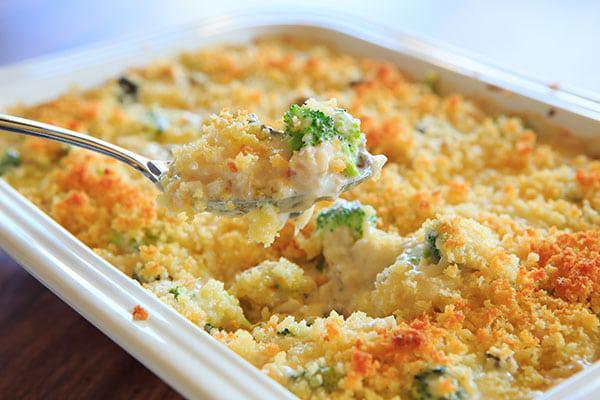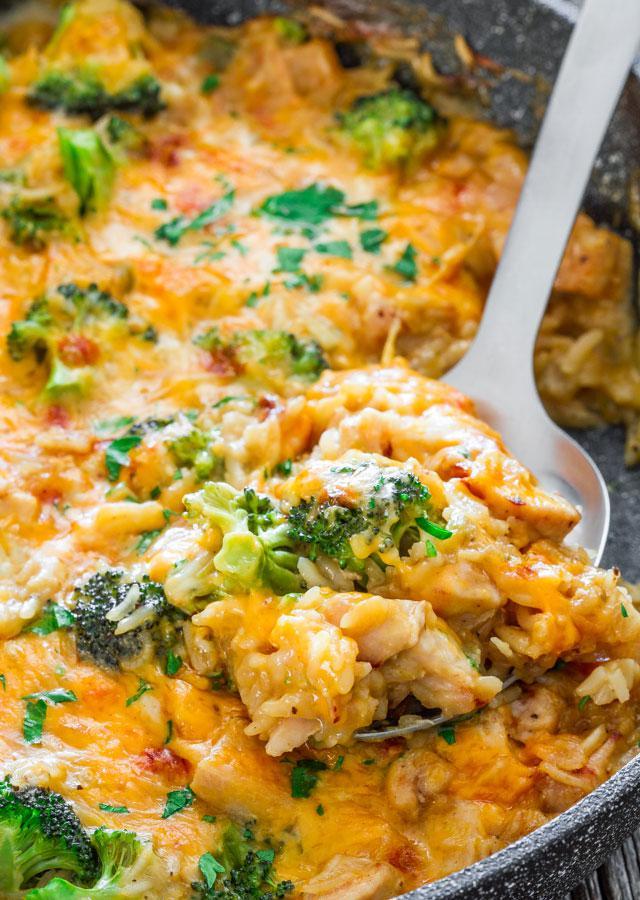The first image is the image on the left, the second image is the image on the right. Considering the images on both sides, is "In one image, the casserole is intact, and in the other image, part of it has been served and a wooden spoon can be seen." valid? Answer yes or no. No. The first image is the image on the left, the second image is the image on the right. Evaluate the accuracy of this statement regarding the images: "A wooden spoon is stirring the food in the image on the right.". Is it true? Answer yes or no. No. 